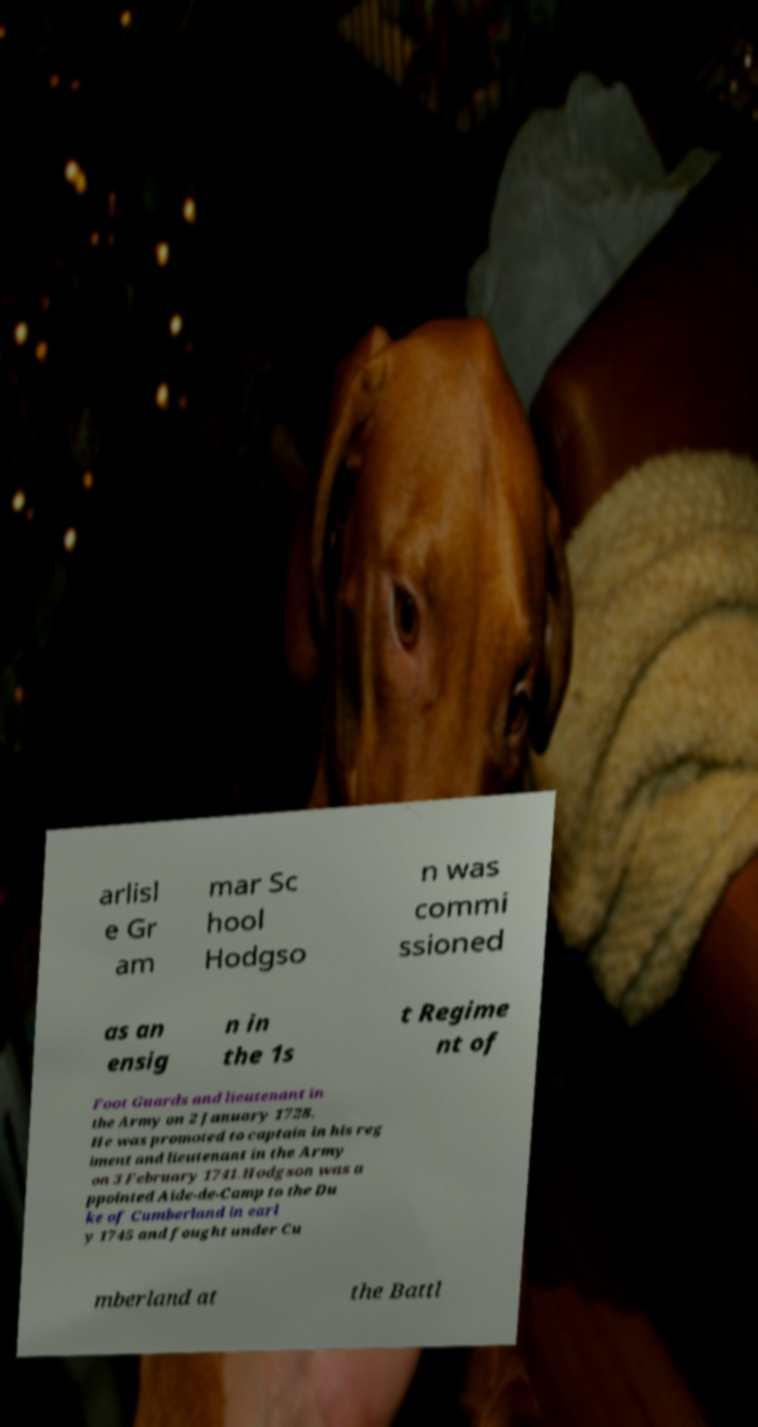Can you accurately transcribe the text from the provided image for me? arlisl e Gr am mar Sc hool Hodgso n was commi ssioned as an ensig n in the 1s t Regime nt of Foot Guards and lieutenant in the Army on 2 January 1728. He was promoted to captain in his reg iment and lieutenant in the Army on 3 February 1741.Hodgson was a ppointed Aide-de-Camp to the Du ke of Cumberland in earl y 1745 and fought under Cu mberland at the Battl 